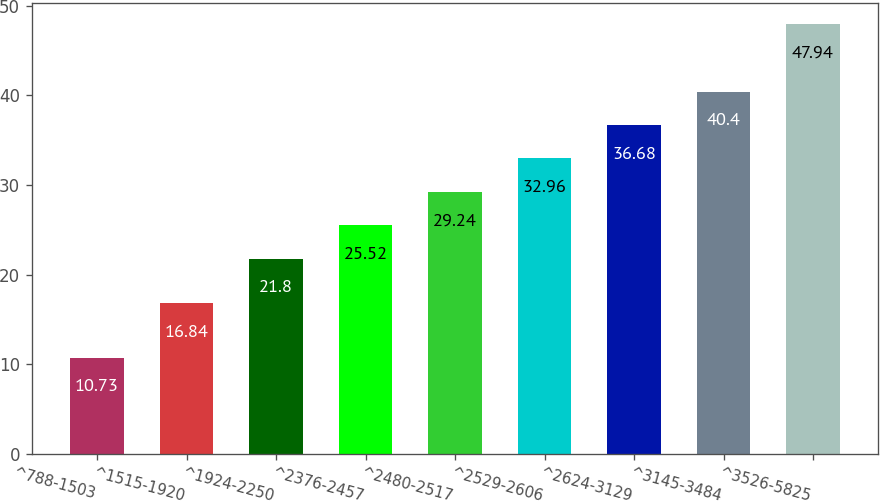<chart> <loc_0><loc_0><loc_500><loc_500><bar_chart><fcel>^788-1503<fcel>^1515-1920<fcel>^1924-2250<fcel>^2376-2457<fcel>^2480-2517<fcel>^2529-2606<fcel>^2624-3129<fcel>^3145-3484<fcel>^3526-5825<nl><fcel>10.73<fcel>16.84<fcel>21.8<fcel>25.52<fcel>29.24<fcel>32.96<fcel>36.68<fcel>40.4<fcel>47.94<nl></chart> 